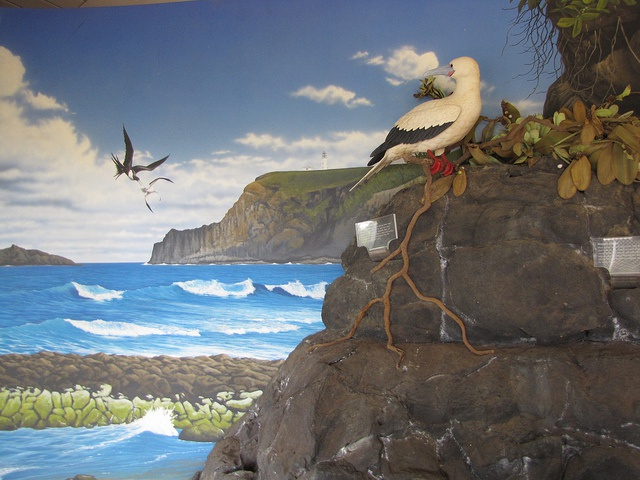Describe the objects in this image and their specific colors. I can see bird in black and tan tones, bird in black, gray, and darkgray tones, and bird in black, lightgray, darkgray, and gray tones in this image. 